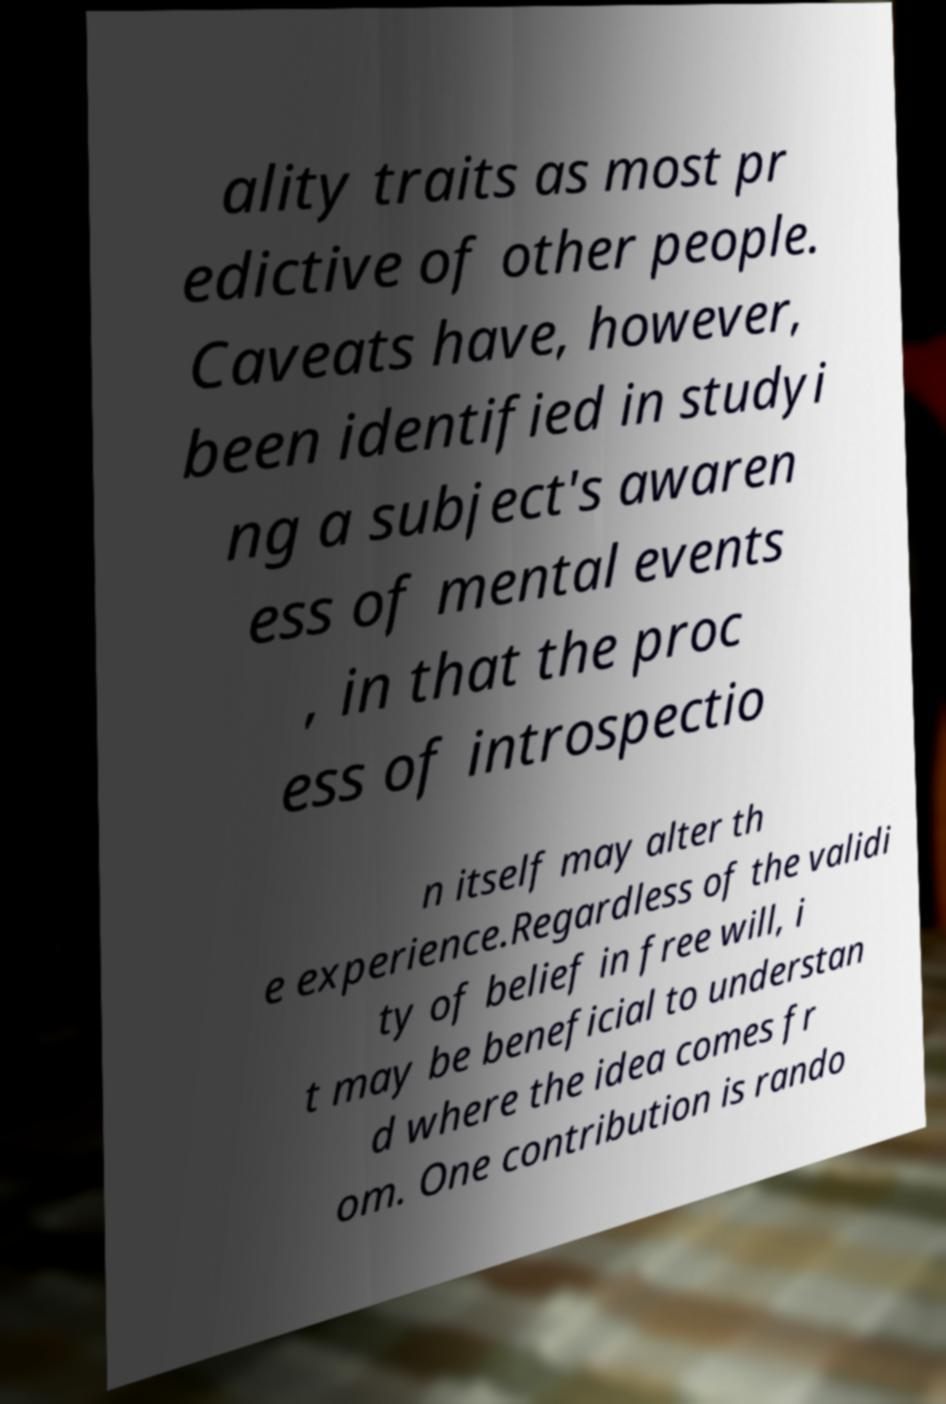I need the written content from this picture converted into text. Can you do that? ality traits as most pr edictive of other people. Caveats have, however, been identified in studyi ng a subject's awaren ess of mental events , in that the proc ess of introspectio n itself may alter th e experience.Regardless of the validi ty of belief in free will, i t may be beneficial to understan d where the idea comes fr om. One contribution is rando 